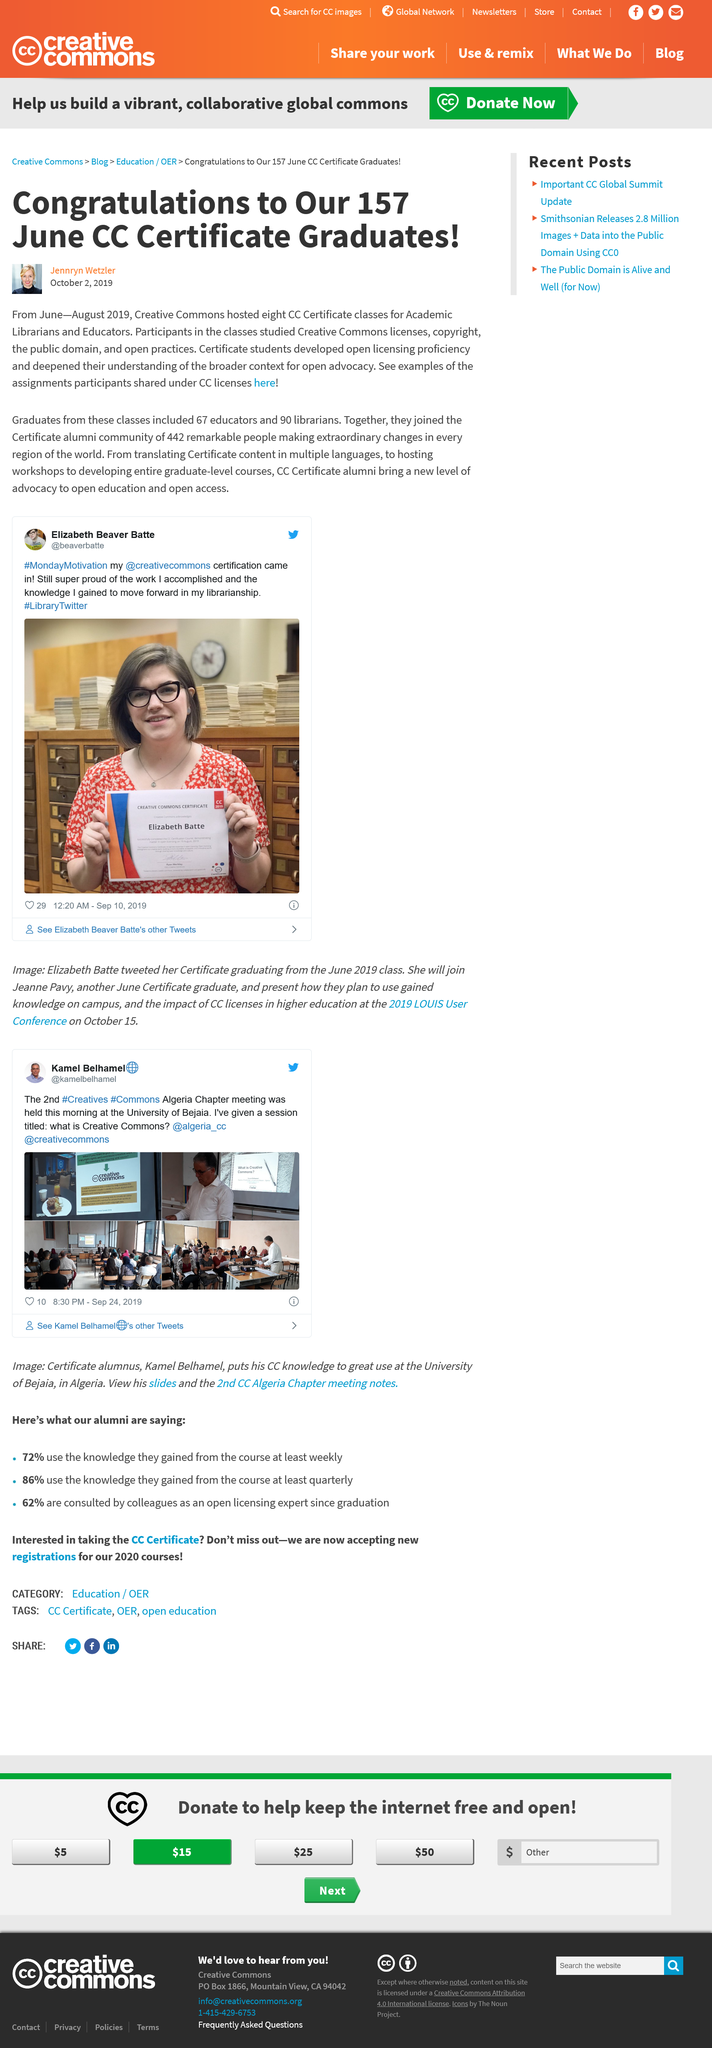Draw attention to some important aspects in this diagram. Nine librarians graduated in June. In June, 67 educators graduated. CC held 8 classes. 